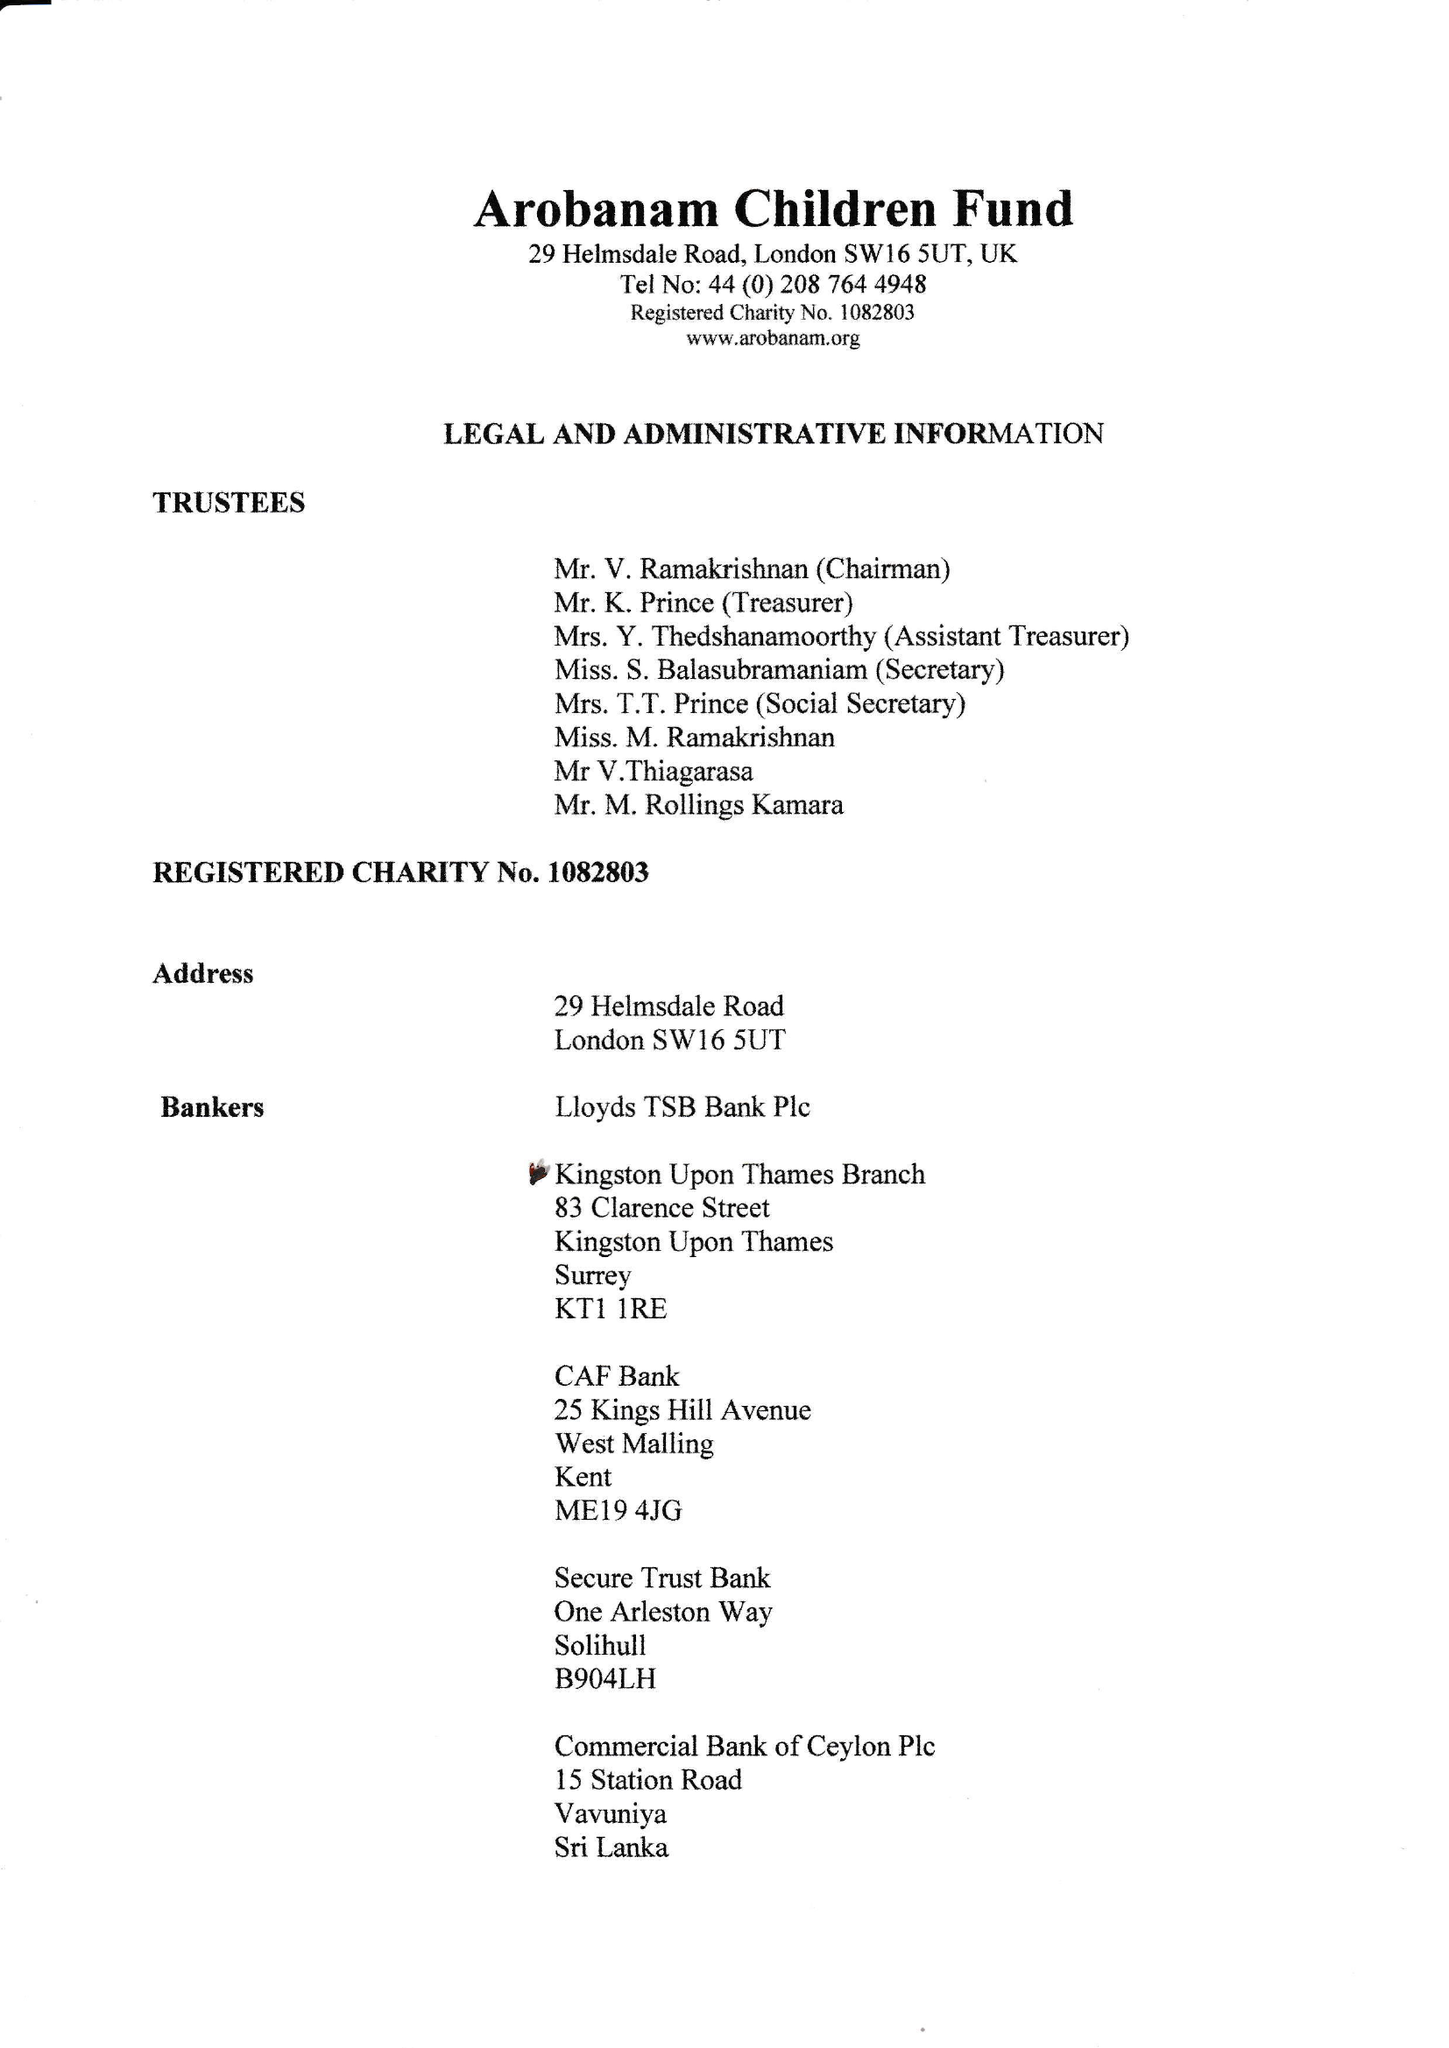What is the value for the charity_number?
Answer the question using a single word or phrase. 1082803 